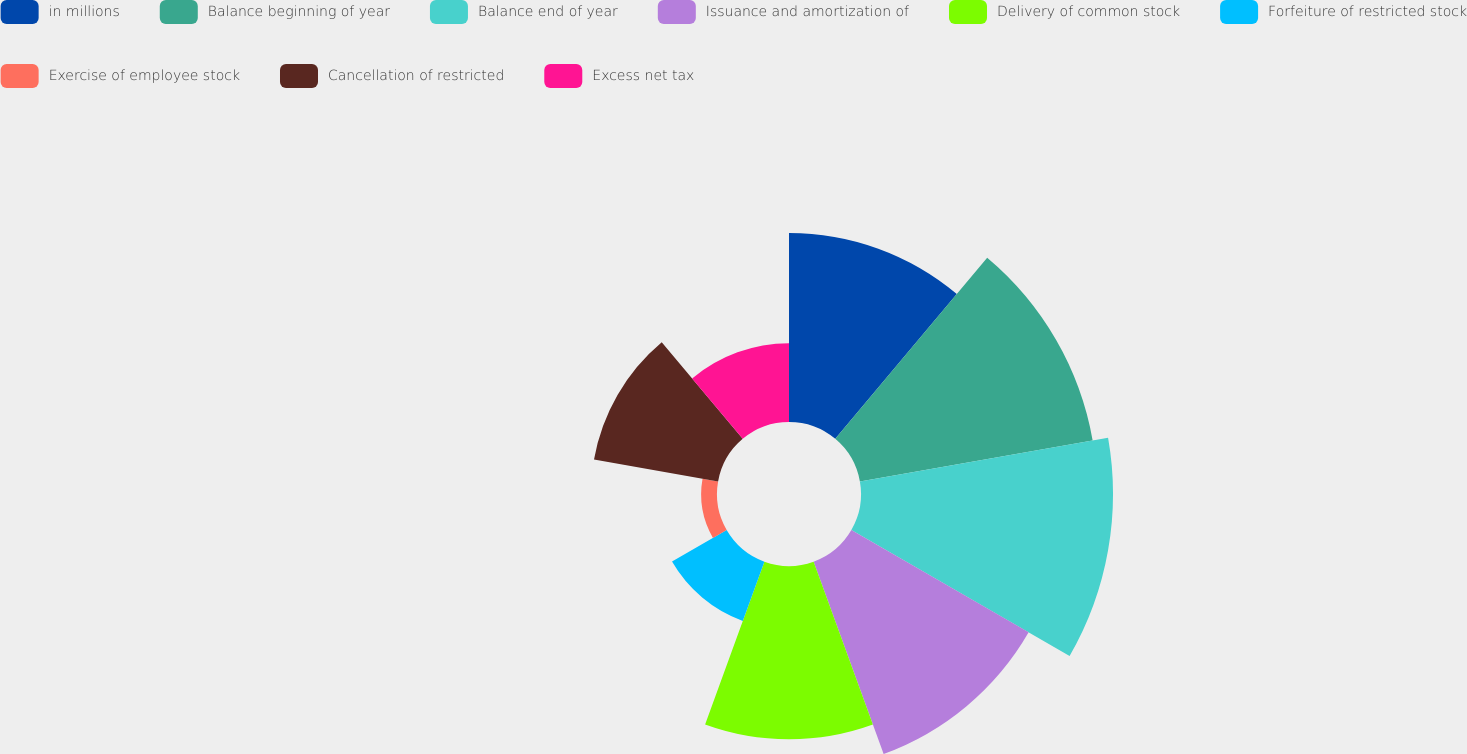<chart> <loc_0><loc_0><loc_500><loc_500><pie_chart><fcel>in millions<fcel>Balance beginning of year<fcel>Balance end of year<fcel>Issuance and amortization of<fcel>Delivery of common stock<fcel>Forfeiture of restricted stock<fcel>Exercise of employee stock<fcel>Cancellation of restricted<fcel>Excess net tax<nl><fcel>14.12%<fcel>17.65%<fcel>18.82%<fcel>15.29%<fcel>12.94%<fcel>4.71%<fcel>1.18%<fcel>9.41%<fcel>5.88%<nl></chart> 